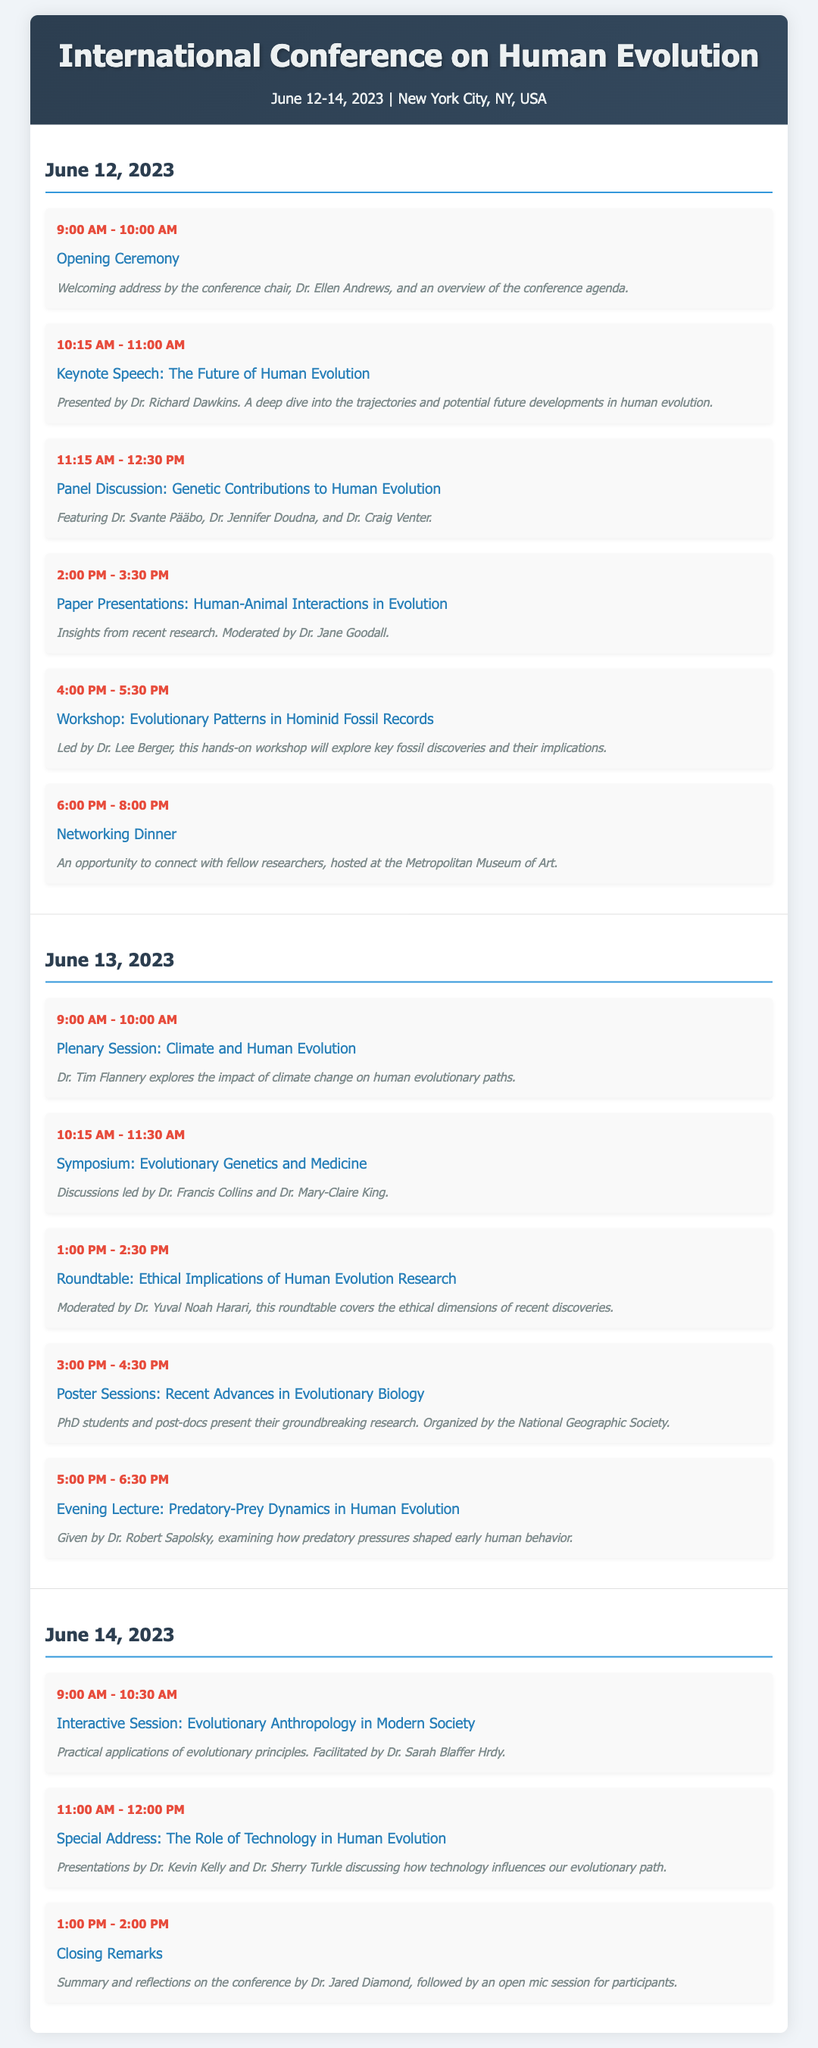What is the date range of the conference? The date range is specified in the header of the document, indicating when the conference takes place.
Answer: June 12-14, 2023 Who delivers the keynote speech? The document mentions the keynote speech and the person giving it, which is a critical highlight of the conference schedule.
Answer: Dr. Richard Dawkins What is the theme of the evening lecture? The title of the evening lecture provides insight into the focus of that particular session during the conference.
Answer: Predatory-Prey Dynamics in Human Evolution How many days does the conference span? This can be counted by looking at the number of distinct days mentioned in the schedule.
Answer: 3 days What is the start time of the closing remarks? The timing of the closing remarks is explicitly mentioned in the schedule section of the document.
Answer: 1:00 PM Which event is moderated by Dr. Yuval Noah Harari? By examining the roundtable description, we can find out which event he is associated with during the conference.
Answer: Roundtable: Ethical Implications of Human Evolution Research What venue hosts the networking dinner? The document specifies the location where the networking dinner is being held for the attendees.
Answer: Metropolitan Museum of Art 